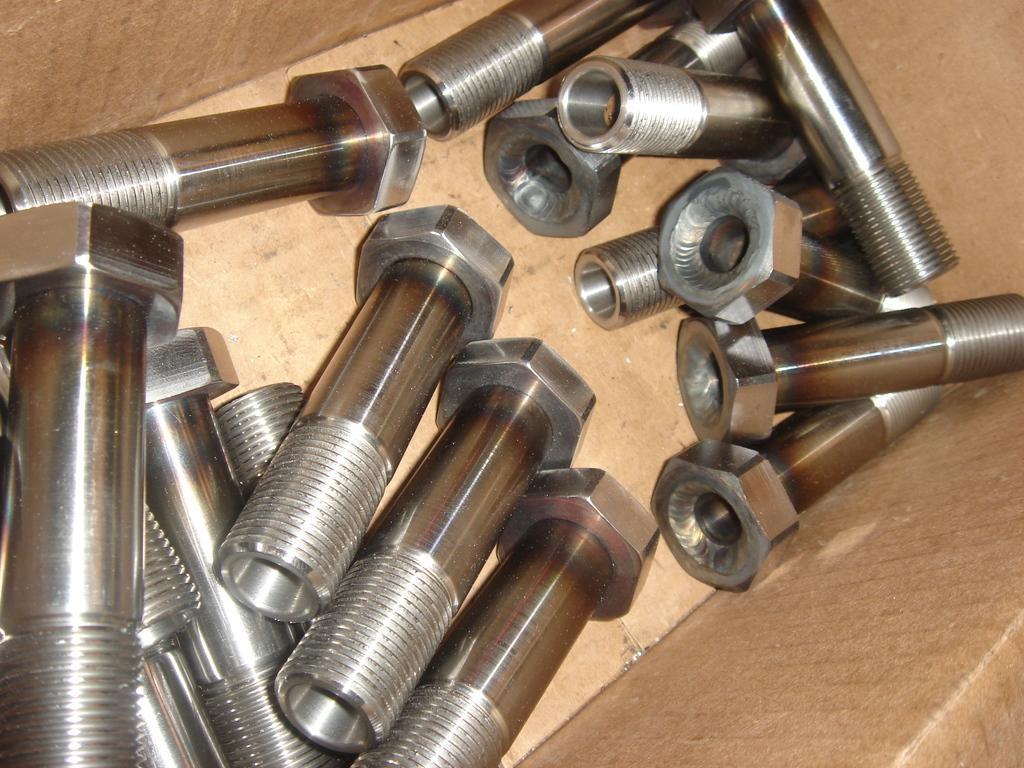In one or two sentences, can you explain what this image depicts? In this image, we can see bolts in a box. 